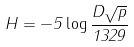Convert formula to latex. <formula><loc_0><loc_0><loc_500><loc_500>H = - 5 \log \frac { D \sqrt { p } } { 1 3 2 9 }</formula> 